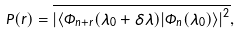Convert formula to latex. <formula><loc_0><loc_0><loc_500><loc_500>P ( r ) = \overline { \left | \left \langle \Phi _ { n + r } ( \lambda _ { 0 } + \delta \lambda ) | \Phi _ { n } ( \lambda _ { 0 } ) \right \rangle \right | ^ { 2 } } ,</formula> 